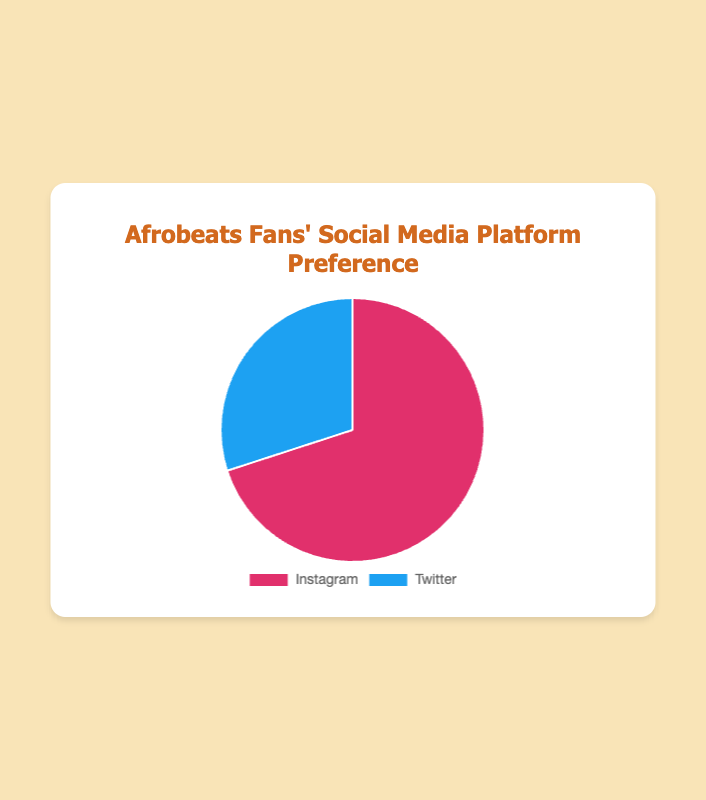Which social media platform do most Afrobeats fans prefer? The chart shows that Instagram has a larger segment than Twitter. Instagram is at 70%, while Twitter is at 30%.
Answer: Instagram What percentage of Afrobeats fans prefer Twitter? The chart indicates that 30% of Afrobeats fans prefer Twitter.
Answer: 30% By how much percent is Instagram more preferred than Twitter among Afrobeats fans? Instagram is at 70% and Twitter is at 30%. The difference in preference is 70% - 30% = 40%.
Answer: 40% If there were 1000 Afrobeats fans surveyed, how many would prefer Instagram? Given that 70% of Afrobeats fans prefer Instagram, we calculate 70% of 1000. That is, 0.70 * 1000 = 700 fans prefer Instagram.
Answer: 700 Which of the two platforms has a smaller segment in the pie chart? Visually, the segment representing Twitter is smaller than the one representing Instagram.
Answer: Twitter Combining the percentages, what is the total percentage accounted for by the two platforms? Adding the two percentages together: 70% + 30% = 100%.
Answer: 100% If an Afrobeats artist wants to choose one platform to maximize their reach, which platform should they choose based on this data? Since 70% of Afrobeats fans prefer Instagram, it would maximize their reach compared to Twitter, which has only 30% preference.
Answer: Instagram Is there a significant difference in the preference for Instagram over Twitter among Afrobeats fans? The difference is 40% (70% for Instagram vs. 30% for Twitter), which is a notable and significant gap.
Answer: Yes Which color represents Instagram in the pie chart? The chart uses a distinct color for each platform: Instagram is represented by a color similar to pink or purple.
Answer: Pink/Purple If another social media platform were introduced and it took 20% of the Afrobeats fans, what would be the new percentage for Instagram? If a new platform takes 20%, the remaining 80% would be distributed between Instagram and Twitter. Instagram's adjusted share would be 70% of the remaining 80%, which is 0.70 * 80 = 56%.
Answer: 56% 